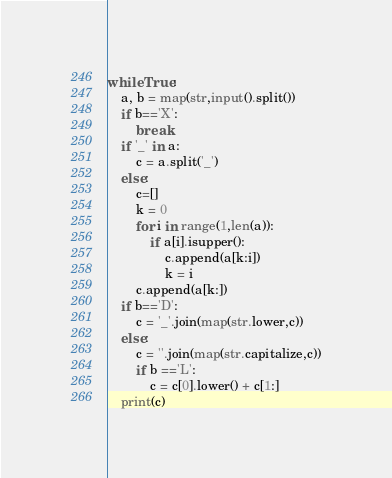<code> <loc_0><loc_0><loc_500><loc_500><_Python_>while True:
    a, b = map(str,input().split())
    if b=='X':
        break
    if '_' in a:
        c = a.split('_')
    else:
        c=[]
        k = 0
        for i in range(1,len(a)):
            if a[i].isupper():
                c.append(a[k:i])
                k = i
        c.append(a[k:])
    if b=='D':
        c = '_'.join(map(str.lower,c))
    else:
        c = ''.join(map(str.capitalize,c))
        if b =='L':
            c = c[0].lower() + c[1:]
    print(c)
</code> 